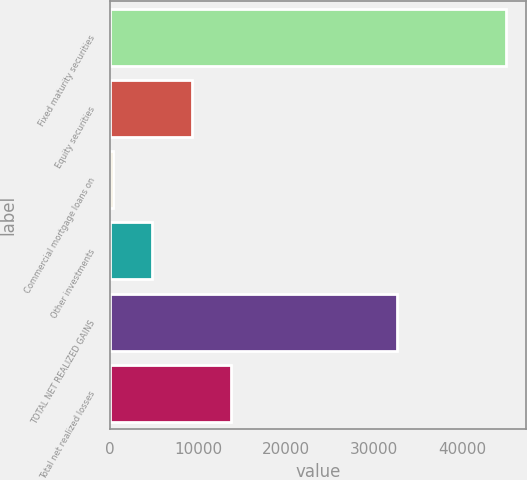Convert chart to OTSL. <chart><loc_0><loc_0><loc_500><loc_500><bar_chart><fcel>Fixed maturity securities<fcel>Equity securities<fcel>Commercial mortgage loans on<fcel>Other investments<fcel>TOTAL NET REALIZED GAINS<fcel>Total net realized losses<nl><fcel>44924<fcel>9253.6<fcel>336<fcel>4794.8<fcel>32580<fcel>13712.4<nl></chart> 